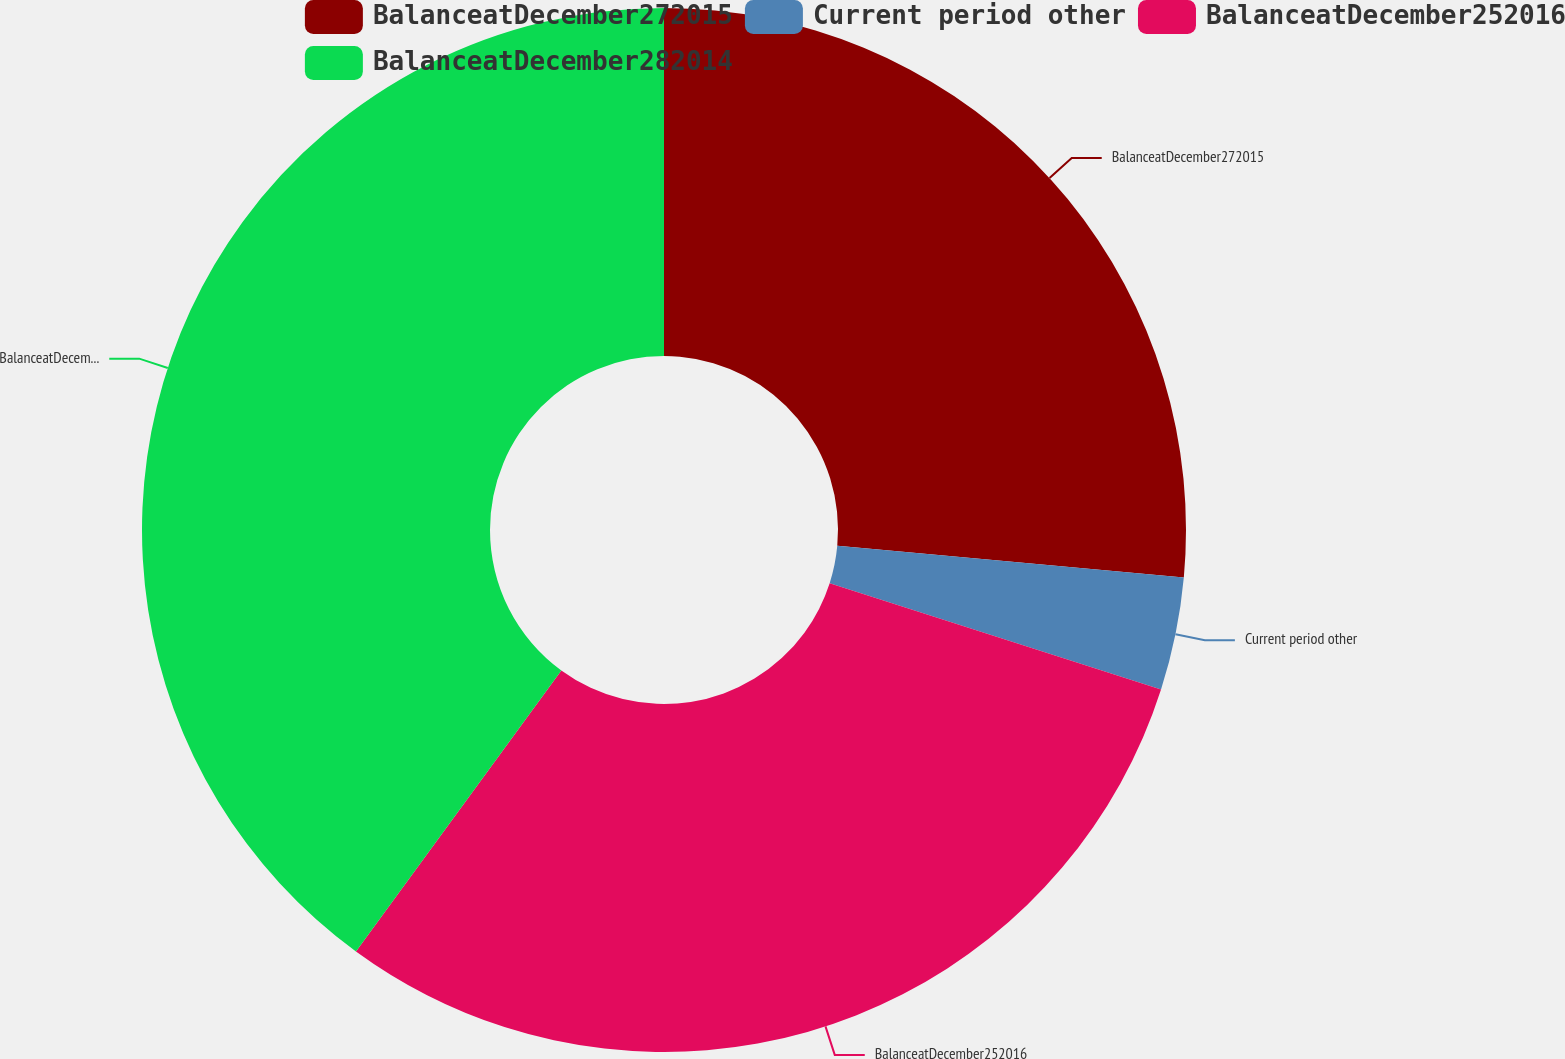Convert chart. <chart><loc_0><loc_0><loc_500><loc_500><pie_chart><fcel>BalanceatDecember272015<fcel>Current period other<fcel>BalanceatDecember252016<fcel>BalanceatDecember282014<nl><fcel>26.45%<fcel>3.49%<fcel>30.1%<fcel>39.95%<nl></chart> 